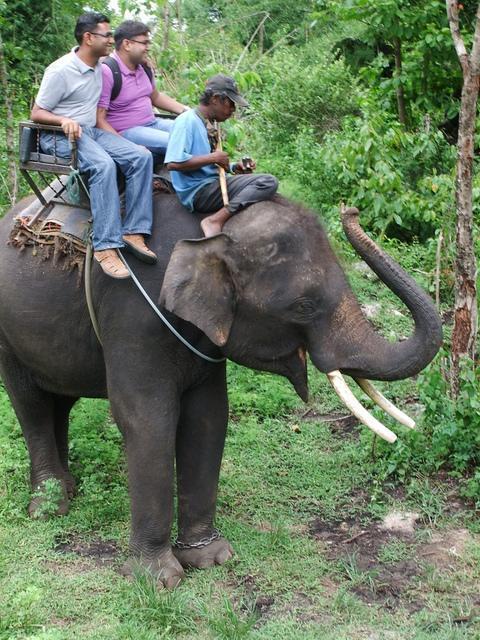How many people are riding the elephant?
Give a very brief answer. 3. How many people are visible?
Give a very brief answer. 3. 